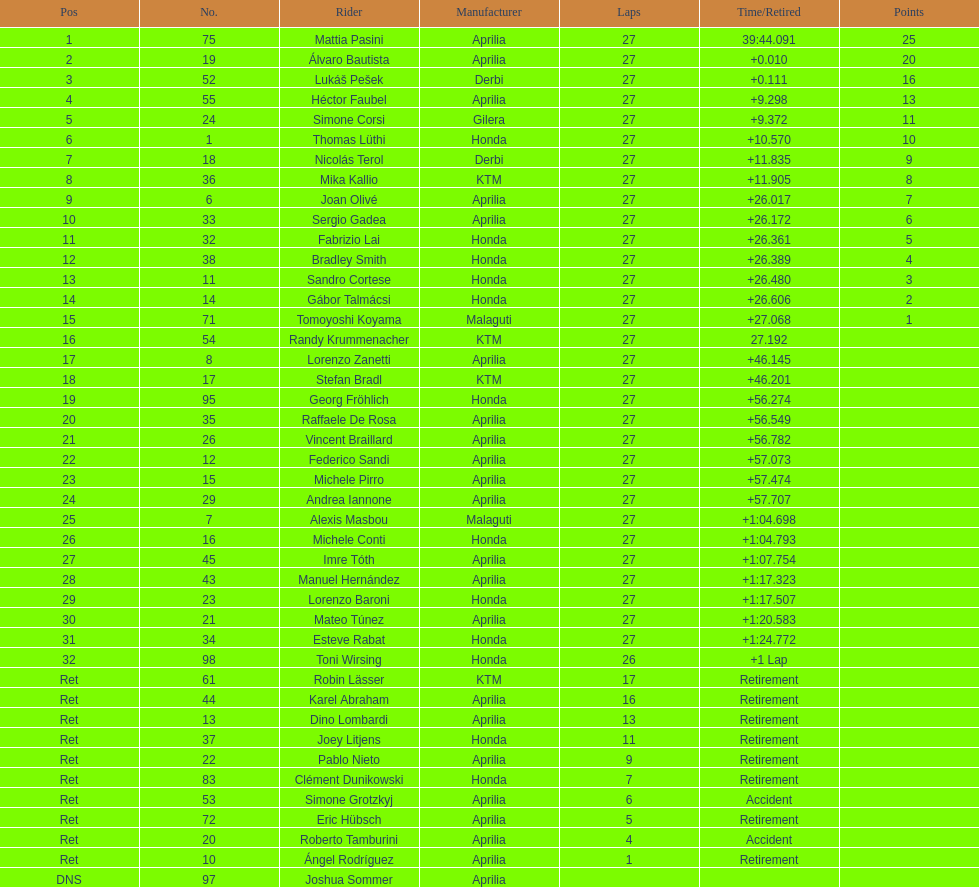Of everyone holding points, who has the minimum? Tomoyoshi Koyama. 